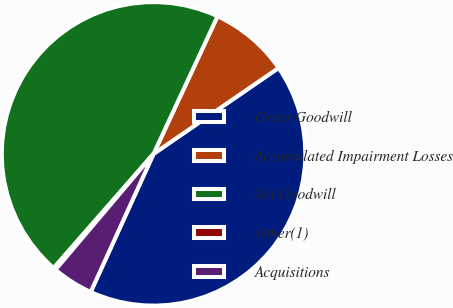Convert chart. <chart><loc_0><loc_0><loc_500><loc_500><pie_chart><fcel>Gross Goodwill<fcel>Accumulated Impairment Losses<fcel>Net Goodwill<fcel>Other(1)<fcel>Acquisitions<nl><fcel>41.38%<fcel>8.49%<fcel>45.49%<fcel>0.26%<fcel>4.38%<nl></chart> 